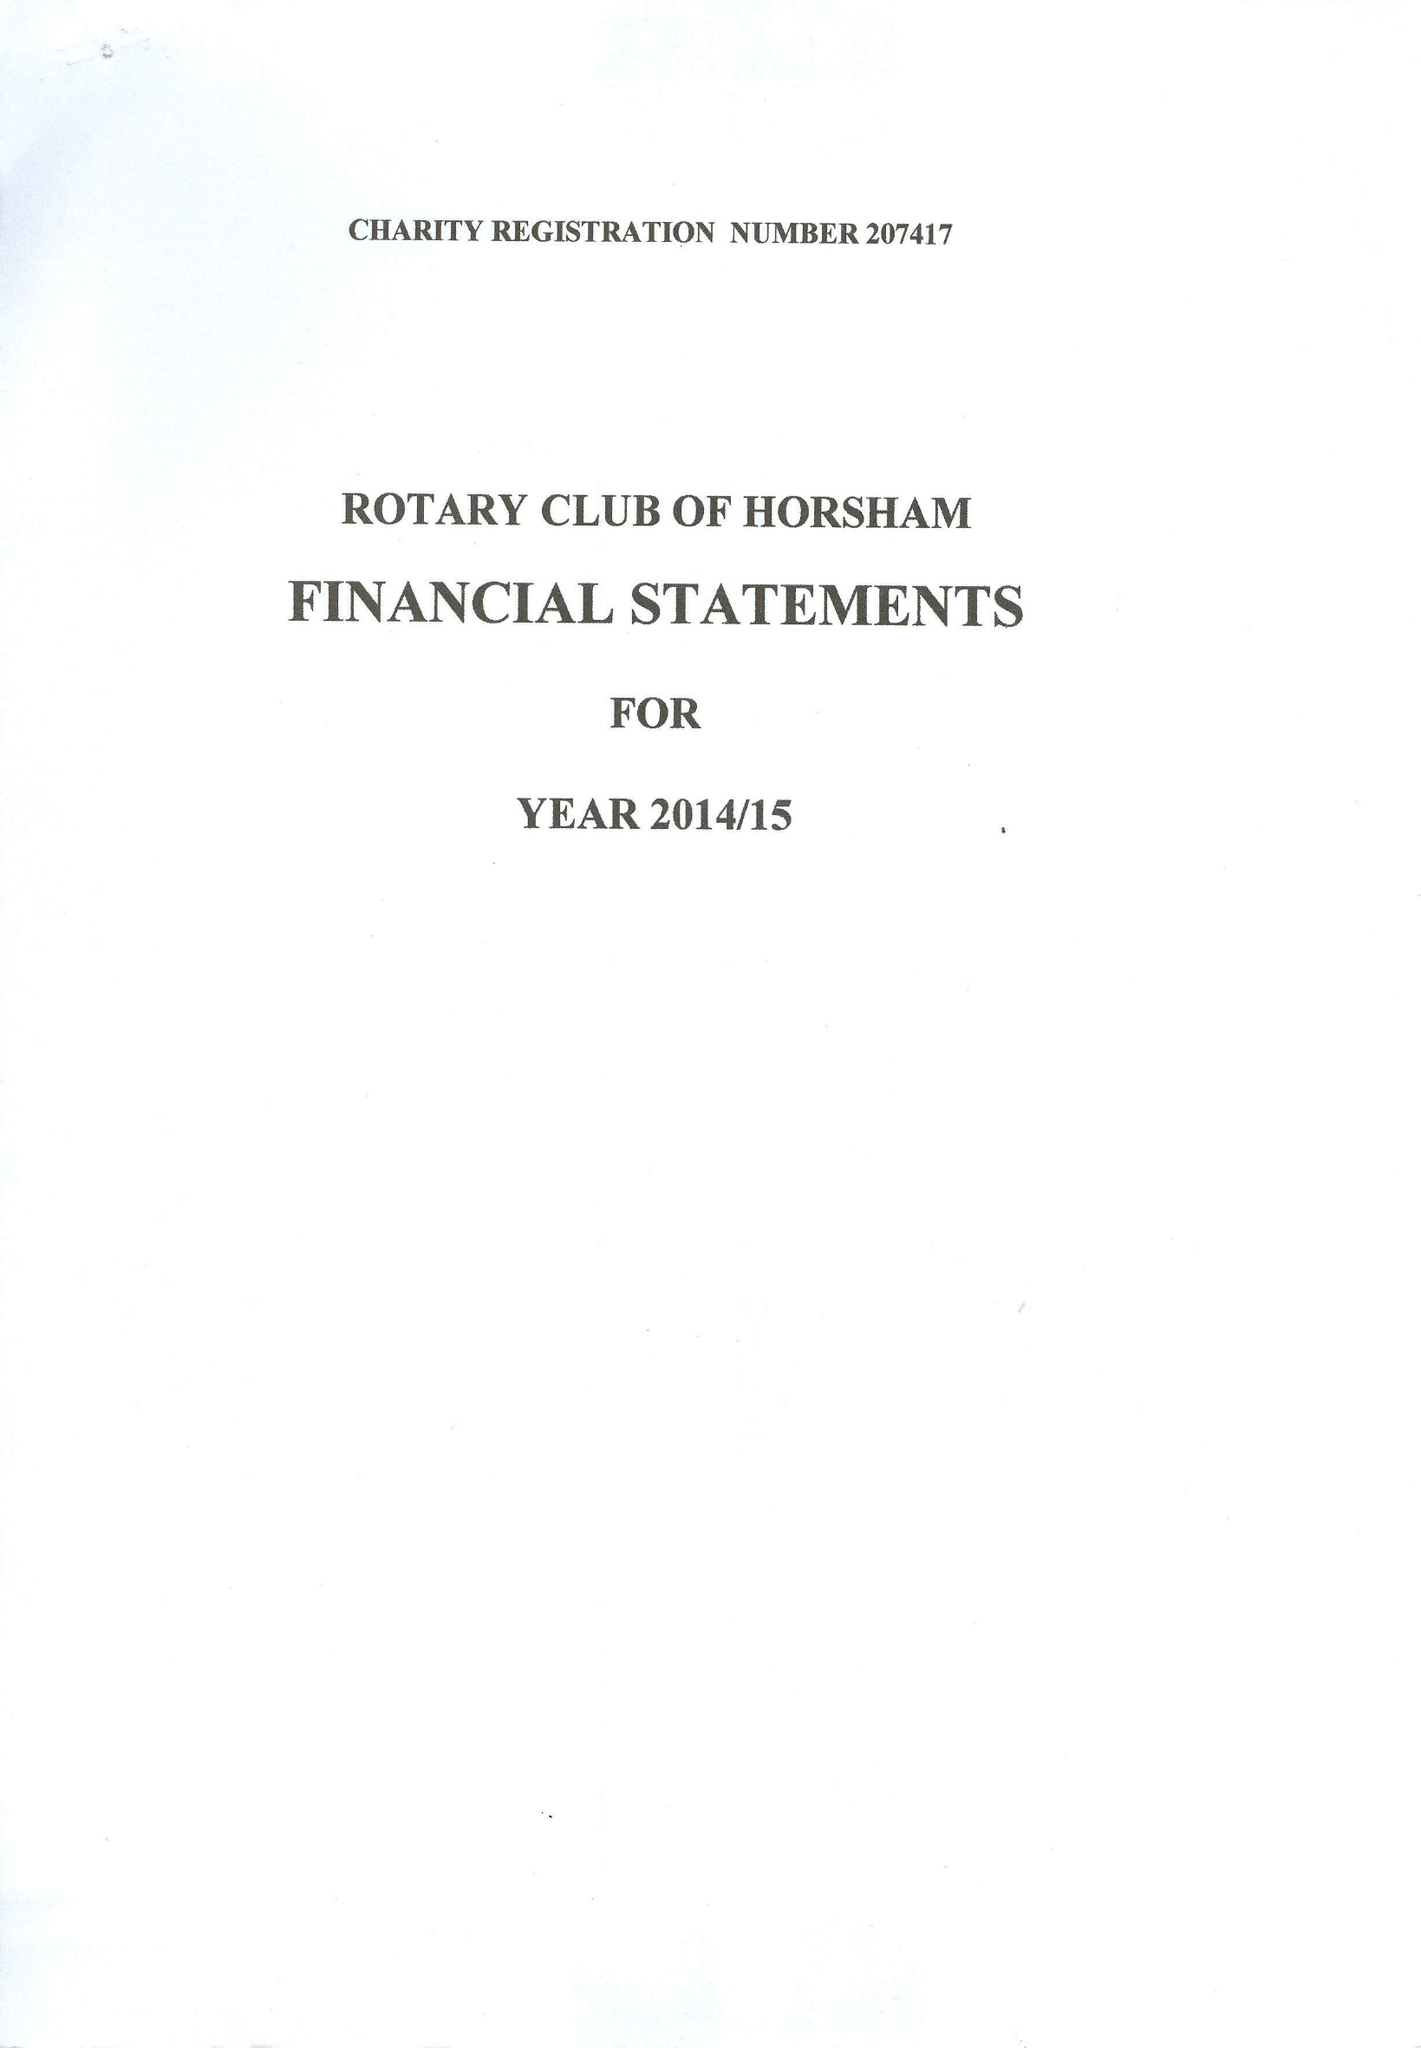What is the value for the charity_name?
Answer the question using a single word or phrase. The Rotary Club Of Horsham Benevolent Fund 